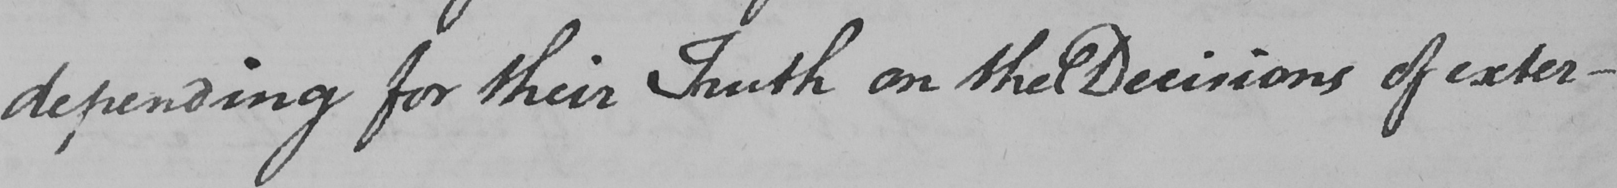Please transcribe the handwritten text in this image. depending for their Truth on the Decisions of exter- 